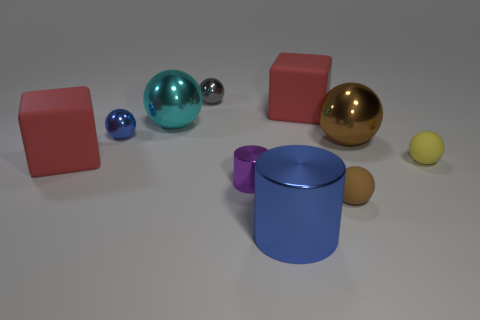Subtract 1 balls. How many balls are left? 5 Subtract all gray balls. How many balls are left? 5 Subtract all blue metal spheres. How many spheres are left? 5 Subtract all gray balls. Subtract all gray cubes. How many balls are left? 5 Subtract all cylinders. How many objects are left? 8 Add 1 big cylinders. How many big cylinders exist? 2 Subtract 1 blue cylinders. How many objects are left? 9 Subtract all purple things. Subtract all blocks. How many objects are left? 7 Add 1 small objects. How many small objects are left? 6 